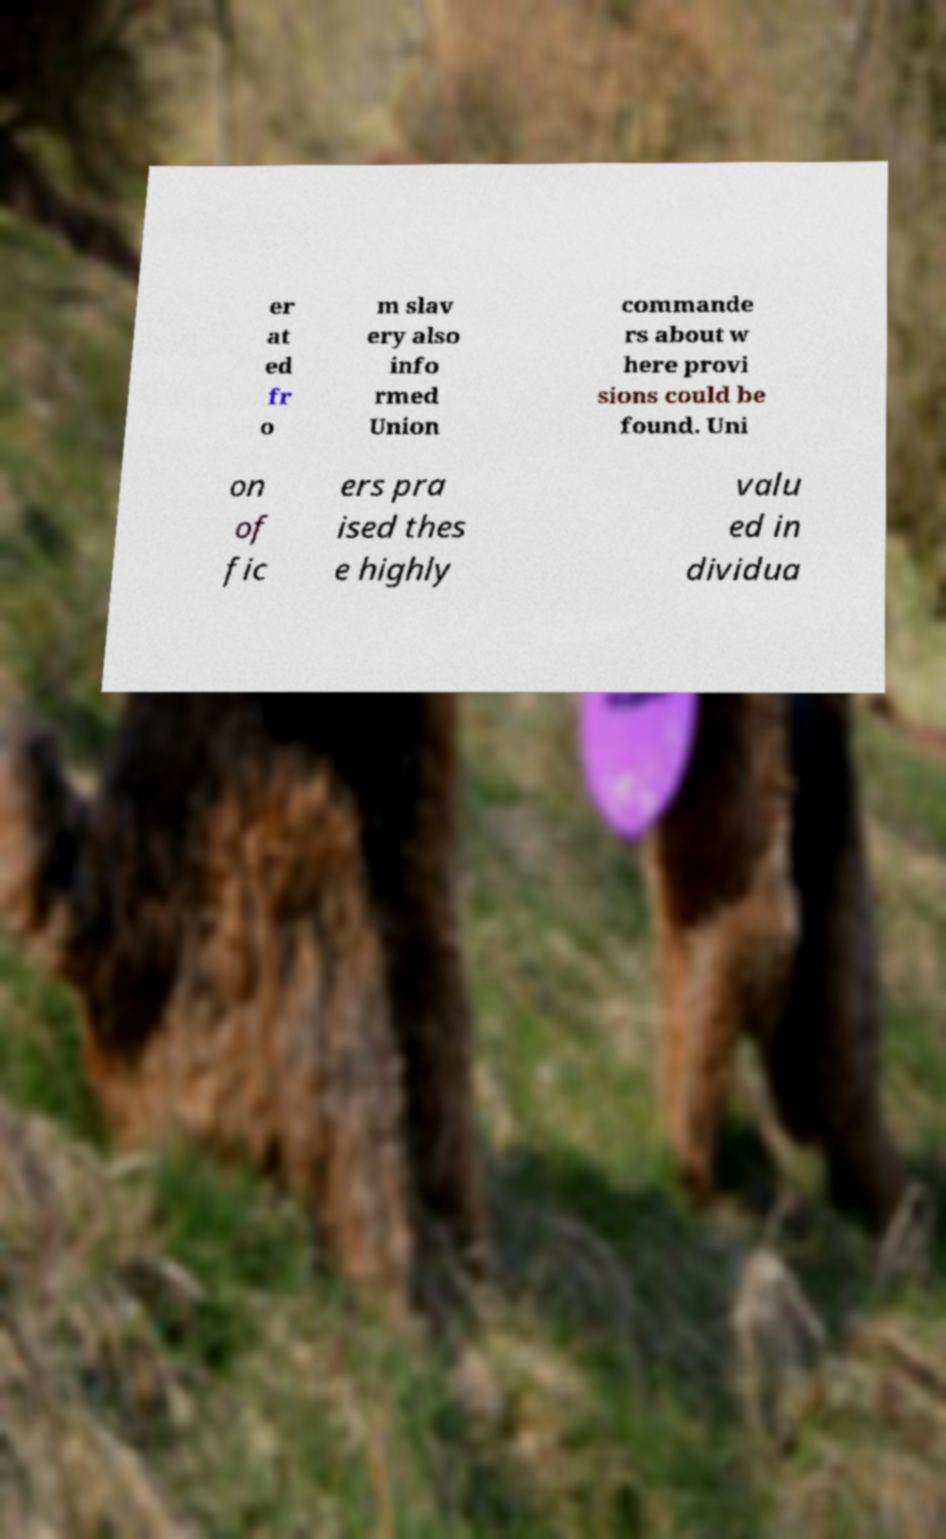For documentation purposes, I need the text within this image transcribed. Could you provide that? er at ed fr o m slav ery also info rmed Union commande rs about w here provi sions could be found. Uni on of fic ers pra ised thes e highly valu ed in dividua 